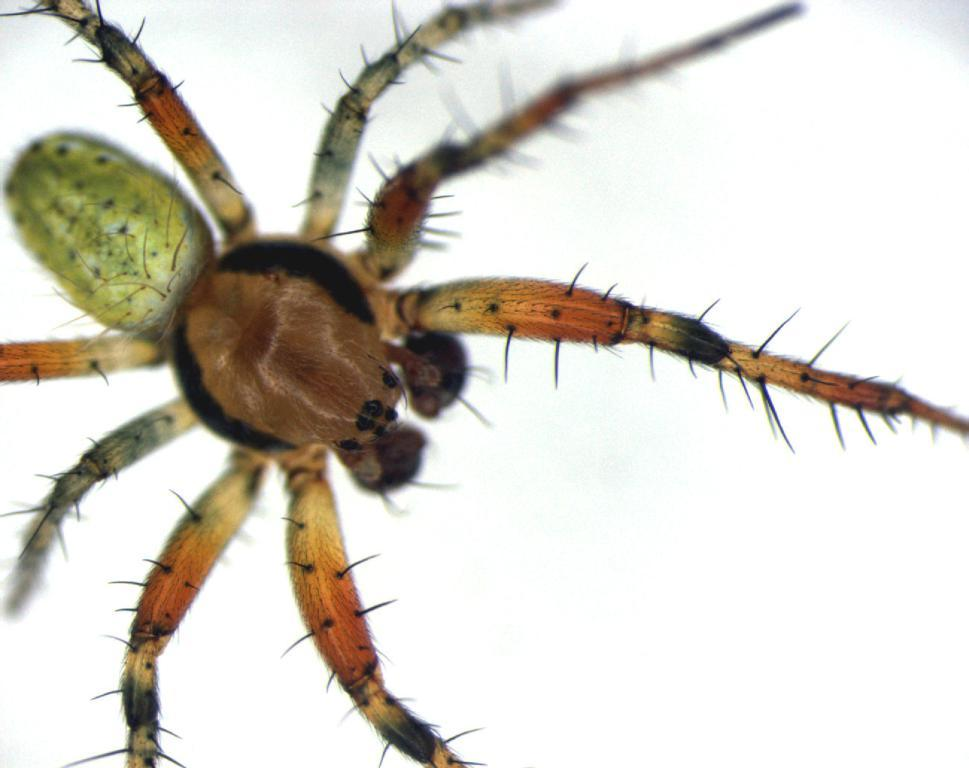What type of creature can be seen in the image? There is an insect in the image. What color is the background of the image? The background of the image is white. What type of behavior can be observed in the insect's hearing in the image? There is no information about the insect's hearing in the image, and therefore no such behavior can be observed. 